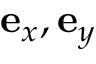<formula> <loc_0><loc_0><loc_500><loc_500>e _ { x } , e _ { y }</formula> 